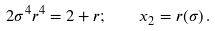Convert formula to latex. <formula><loc_0><loc_0><loc_500><loc_500>2 \sigma ^ { 4 } r ^ { 4 } = 2 + r ; \quad x _ { 2 } = r ( \sigma ) \, .</formula> 